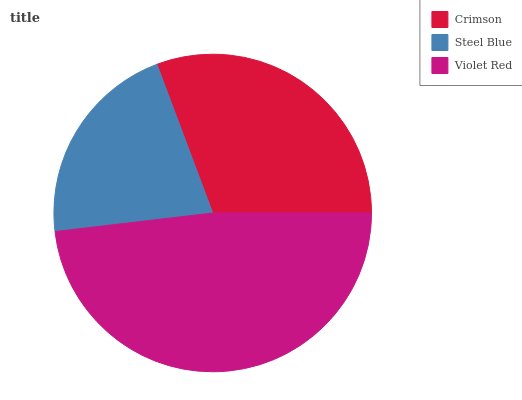Is Steel Blue the minimum?
Answer yes or no. Yes. Is Violet Red the maximum?
Answer yes or no. Yes. Is Violet Red the minimum?
Answer yes or no. No. Is Steel Blue the maximum?
Answer yes or no. No. Is Violet Red greater than Steel Blue?
Answer yes or no. Yes. Is Steel Blue less than Violet Red?
Answer yes or no. Yes. Is Steel Blue greater than Violet Red?
Answer yes or no. No. Is Violet Red less than Steel Blue?
Answer yes or no. No. Is Crimson the high median?
Answer yes or no. Yes. Is Crimson the low median?
Answer yes or no. Yes. Is Violet Red the high median?
Answer yes or no. No. Is Violet Red the low median?
Answer yes or no. No. 